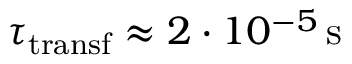<formula> <loc_0><loc_0><loc_500><loc_500>\tau _ { t r a n s f } \approx 2 \cdot 1 0 ^ { - 5 } \, s</formula> 